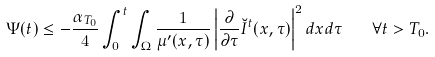<formula> <loc_0><loc_0><loc_500><loc_500>\Psi ( t ) \leq - \frac { \alpha _ { T _ { 0 } } } 4 \int _ { 0 } ^ { t } \int _ { \Omega } \frac { 1 } { \mu ^ { \prime } ( x , \tau ) } \left | \frac { \partial } { \partial \tau } \breve { I } ^ { t } ( x , \tau ) \right | ^ { 2 } d x d \tau \quad \forall t > T _ { 0 } .</formula> 